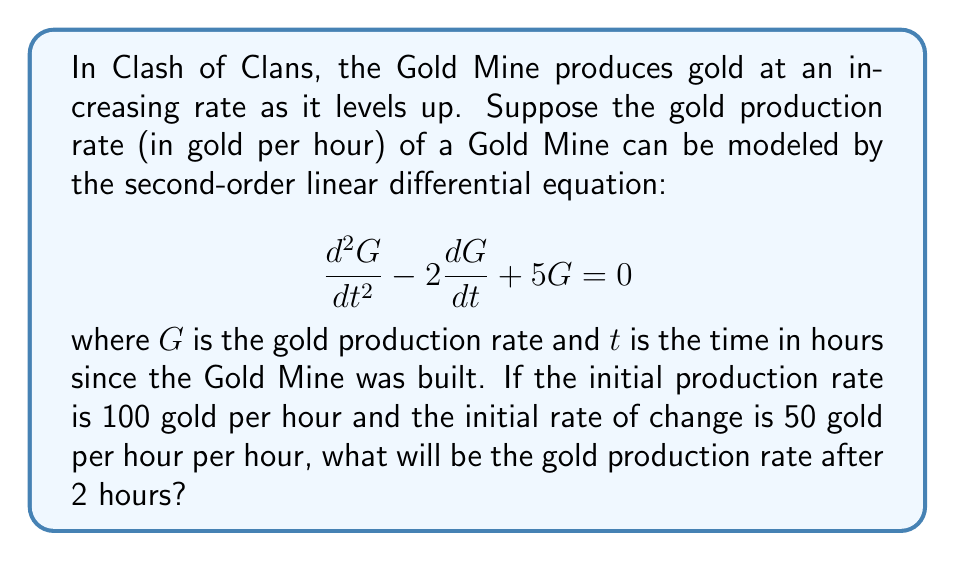Teach me how to tackle this problem. To solve this problem, we need to follow these steps:

1) The general solution for this second-order linear differential equation is:

   $$G(t) = c_1e^{t} + c_2e^{4t}$$

   where $c_1$ and $c_2$ are constants we need to determine.

2) We have two initial conditions:
   - $G(0) = 100$ (initial production rate)
   - $G'(0) = 50$ (initial rate of change)

3) Let's use the first condition:
   
   $$G(0) = c_1e^0 + c_2e^0 = c_1 + c_2 = 100$$

4) For the second condition, we need to differentiate $G(t)$:
   
   $$G'(t) = c_1e^t + 4c_2e^{4t}$$
   
   $$G'(0) = c_1 + 4c_2 = 50$$

5) Now we have a system of two equations:
   
   $$c_1 + c_2 = 100$$
   $$c_1 + 4c_2 = 50$$

6) Subtracting the first equation from the second:
   
   $$3c_2 = -50$$
   $$c_2 = -\frac{50}{3}$$

7) Substituting this back into the first equation:
   
   $$c_1 - \frac{50}{3} = 100$$
   $$c_1 = 100 + \frac{50}{3} = \frac{350}{3}$$

8) Now we have our particular solution:

   $$G(t) = \frac{350}{3}e^t - \frac{50}{3}e^{4t}$$

9) To find the production rate after 2 hours, we calculate $G(2)$:

   $$G(2) = \frac{350}{3}e^2 - \frac{50}{3}e^8$$

10) Using a calculator or computer to evaluate this:

    $$G(2) \approx 1099.45$$

Therefore, after 2 hours, the gold production rate will be approximately 1099.45 gold per hour.
Answer: $1099.45$ gold per hour (rounded to two decimal places) 